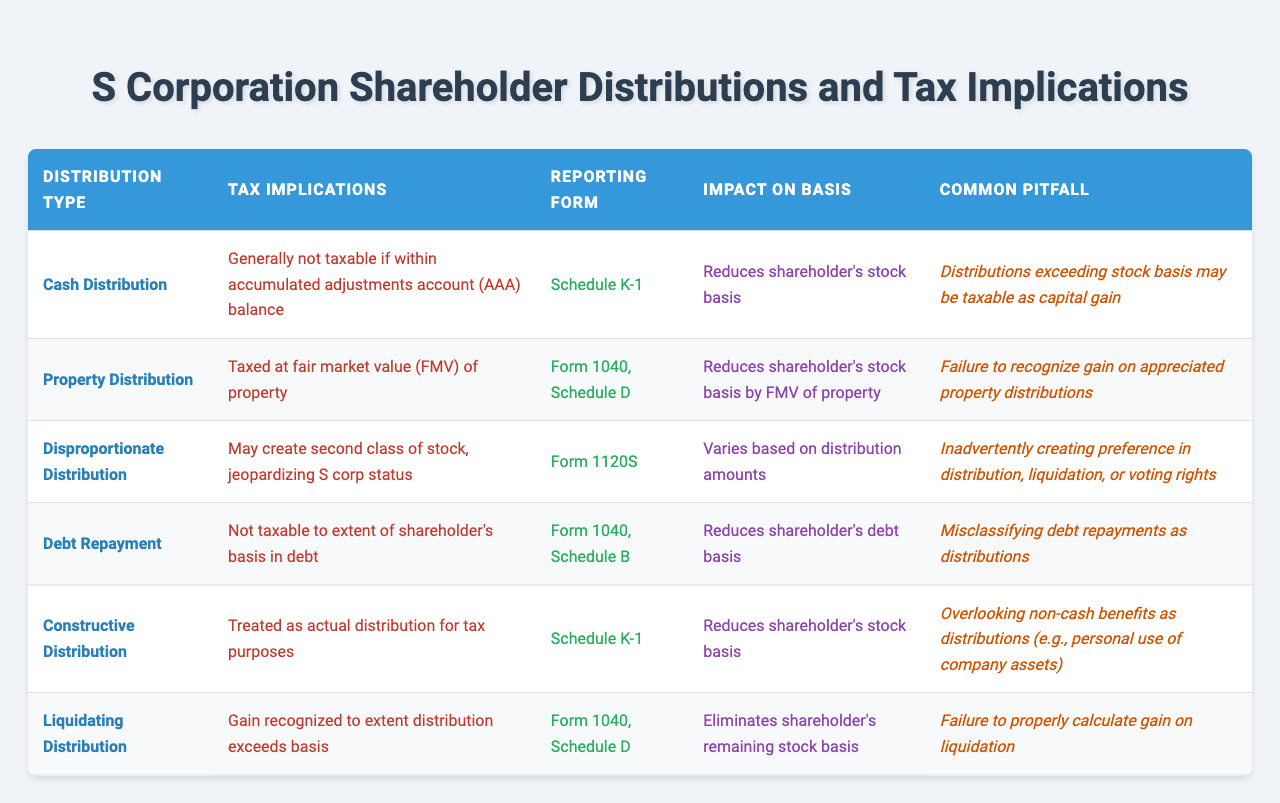What type of distribution is generally not taxable if it is within the accumulated adjustments account balance? The table indicates that a "Cash Distribution" is generally not taxable if it is within the accumulated adjustments account (AAA) balance.
Answer: Cash Distribution Which reporting form is used for property distribution? According to the table, property distributions are reported using Form 1040, Schedule D.
Answer: Form 1040, Schedule D Is a disproportionate distribution likely to jeopardize S corporation status? Yes, the table states that disproportionate distributions may create a second class of stock, jeopardizing S corporation status.
Answer: Yes What impact does a cash distribution have on a shareholder's stock basis? The table shows that a cash distribution reduces the shareholder's stock basis.
Answer: Reduces stock basis What is a common pitfall associated with liquidating distributions? The common pitfall according to the table is the failure to properly calculate the gain on liquidation.
Answer: Failure to calculate gain How many types of distributions are listed in the table? The table lists a total of six types of distributions: Cash Distribution, Property Distribution, Disproportionate Distribution, Debt Repayment, Constructive Distribution, and Liquidating Distribution.
Answer: Six types What is the tax implication of a debt repayment that is classified correctly? It is not taxable to the extent of the shareholder's basis in debt, as per the information in the table.
Answer: Not taxable If a shareholder receives a constructive distribution, what is its tax treatment? The table states that a constructive distribution is treated as an actual distribution for tax purposes.
Answer: Treated as actual distribution List the reporting forms for cash and liquidating distributions. Cash distributions are reported on Schedule K-1, while liquidating distributions are reported on Form 1040, Schedule D, as detailed in the table.
Answer: Schedule K-1 and Form 1040, Schedule D Can exceeding stock basis in distributions lead to capital gains tax? Yes, the table indicates that distributions exceeding stock basis may be taxable as capital gain, confirming that this statement is true.
Answer: Yes 